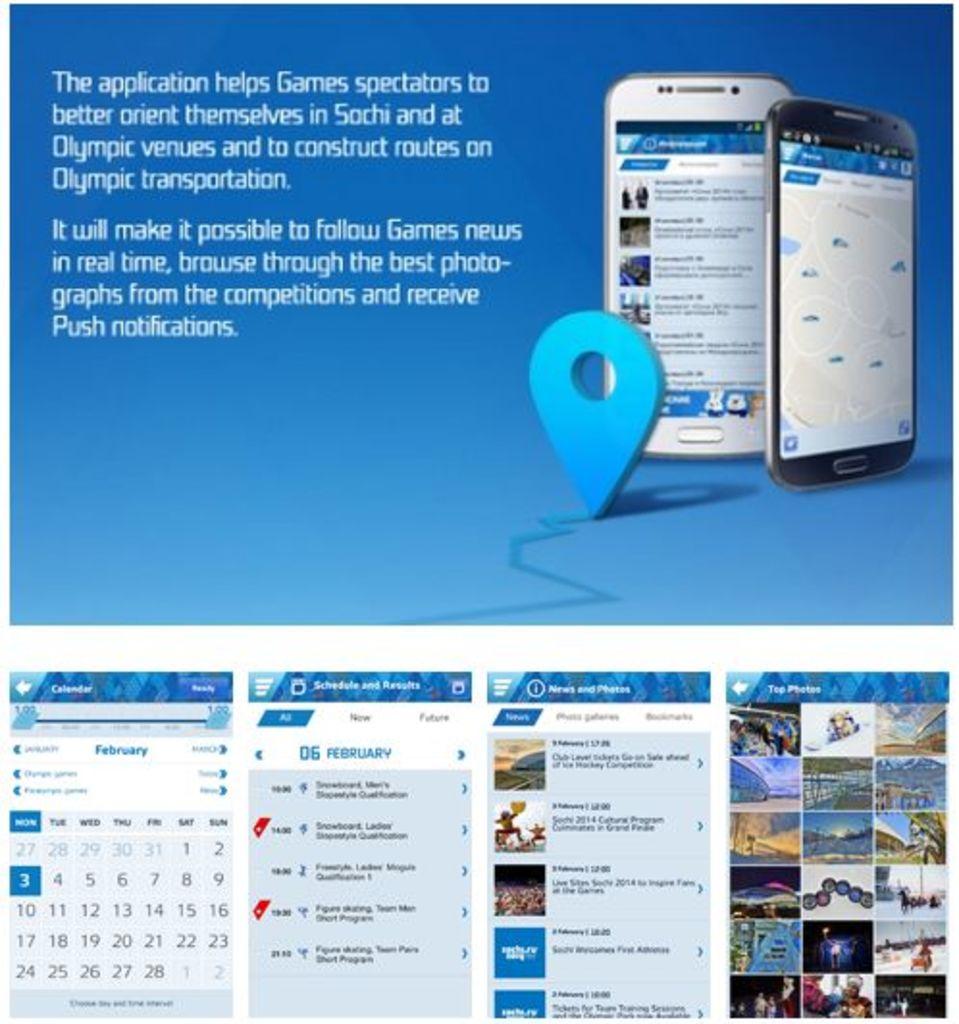What is being advertised?
Your answer should be compact. Application. What month does the calendar display?
Your answer should be compact. February. 